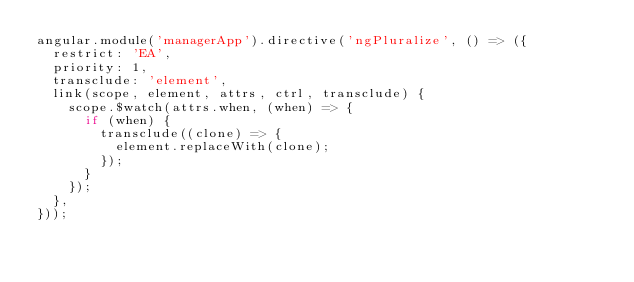Convert code to text. <code><loc_0><loc_0><loc_500><loc_500><_JavaScript_>angular.module('managerApp').directive('ngPluralize', () => ({
  restrict: 'EA',
  priority: 1,
  transclude: 'element',
  link(scope, element, attrs, ctrl, transclude) {
    scope.$watch(attrs.when, (when) => {
      if (when) {
        transclude((clone) => {
          element.replaceWith(clone);
        });
      }
    });
  },
}));
</code> 